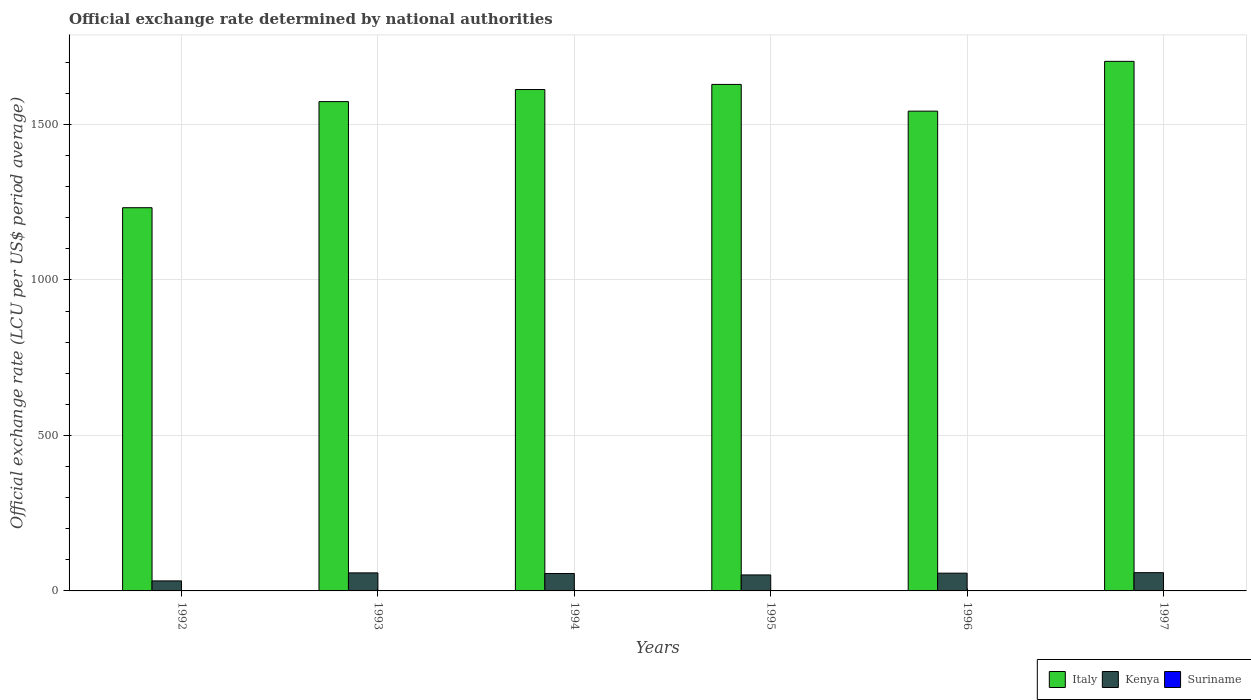Are the number of bars per tick equal to the number of legend labels?
Offer a terse response. Yes. Are the number of bars on each tick of the X-axis equal?
Your answer should be compact. Yes. How many bars are there on the 1st tick from the left?
Your answer should be very brief. 3. How many bars are there on the 5th tick from the right?
Your answer should be very brief. 3. What is the label of the 5th group of bars from the left?
Offer a very short reply. 1996. What is the official exchange rate in Italy in 1996?
Your answer should be very brief. 1542.95. Across all years, what is the maximum official exchange rate in Suriname?
Your answer should be very brief. 0.44. Across all years, what is the minimum official exchange rate in Suriname?
Provide a short and direct response. 0. In which year was the official exchange rate in Italy maximum?
Provide a succinct answer. 1997. What is the total official exchange rate in Kenya in the graph?
Give a very brief answer. 313.55. What is the difference between the official exchange rate in Kenya in 1993 and that in 1996?
Keep it short and to the point. 0.89. What is the difference between the official exchange rate in Suriname in 1992 and the official exchange rate in Italy in 1993?
Ensure brevity in your answer.  -1573.66. What is the average official exchange rate in Kenya per year?
Offer a very short reply. 52.26. In the year 1994, what is the difference between the official exchange rate in Kenya and official exchange rate in Italy?
Offer a terse response. -1556.39. What is the ratio of the official exchange rate in Italy in 1992 to that in 1997?
Offer a terse response. 0.72. Is the official exchange rate in Suriname in 1993 less than that in 1996?
Ensure brevity in your answer.  Yes. Is the difference between the official exchange rate in Kenya in 1992 and 1994 greater than the difference between the official exchange rate in Italy in 1992 and 1994?
Your response must be concise. Yes. What is the difference between the highest and the second highest official exchange rate in Suriname?
Your answer should be very brief. 0.04. What is the difference between the highest and the lowest official exchange rate in Suriname?
Give a very brief answer. 0.44. In how many years, is the official exchange rate in Suriname greater than the average official exchange rate in Suriname taken over all years?
Offer a terse response. 3. What does the 3rd bar from the left in 1993 represents?
Make the answer very short. Suriname. What does the 2nd bar from the right in 1994 represents?
Provide a short and direct response. Kenya. Is it the case that in every year, the sum of the official exchange rate in Kenya and official exchange rate in Suriname is greater than the official exchange rate in Italy?
Make the answer very short. No. How many bars are there?
Make the answer very short. 18. Are all the bars in the graph horizontal?
Your answer should be very brief. No. How many years are there in the graph?
Provide a short and direct response. 6. What is the difference between two consecutive major ticks on the Y-axis?
Provide a succinct answer. 500. Does the graph contain any zero values?
Offer a terse response. No. What is the title of the graph?
Keep it short and to the point. Official exchange rate determined by national authorities. What is the label or title of the X-axis?
Your response must be concise. Years. What is the label or title of the Y-axis?
Give a very brief answer. Official exchange rate (LCU per US$ period average). What is the Official exchange rate (LCU per US$ period average) in Italy in 1992?
Your answer should be very brief. 1232.41. What is the Official exchange rate (LCU per US$ period average) in Kenya in 1992?
Your answer should be compact. 32.22. What is the Official exchange rate (LCU per US$ period average) in Suriname in 1992?
Ensure brevity in your answer.  0. What is the Official exchange rate (LCU per US$ period average) of Italy in 1993?
Provide a succinct answer. 1573.67. What is the Official exchange rate (LCU per US$ period average) in Kenya in 1993?
Your response must be concise. 58. What is the Official exchange rate (LCU per US$ period average) in Suriname in 1993?
Ensure brevity in your answer.  0. What is the Official exchange rate (LCU per US$ period average) in Italy in 1994?
Your answer should be very brief. 1612.44. What is the Official exchange rate (LCU per US$ period average) in Kenya in 1994?
Provide a short and direct response. 56.05. What is the Official exchange rate (LCU per US$ period average) in Suriname in 1994?
Your answer should be very brief. 0.22. What is the Official exchange rate (LCU per US$ period average) in Italy in 1995?
Offer a very short reply. 1628.93. What is the Official exchange rate (LCU per US$ period average) in Kenya in 1995?
Give a very brief answer. 51.43. What is the Official exchange rate (LCU per US$ period average) of Suriname in 1995?
Offer a terse response. 0.44. What is the Official exchange rate (LCU per US$ period average) in Italy in 1996?
Offer a very short reply. 1542.95. What is the Official exchange rate (LCU per US$ period average) of Kenya in 1996?
Keep it short and to the point. 57.11. What is the Official exchange rate (LCU per US$ period average) in Suriname in 1996?
Make the answer very short. 0.4. What is the Official exchange rate (LCU per US$ period average) in Italy in 1997?
Provide a short and direct response. 1703.1. What is the Official exchange rate (LCU per US$ period average) in Kenya in 1997?
Offer a terse response. 58.73. What is the Official exchange rate (LCU per US$ period average) in Suriname in 1997?
Offer a terse response. 0.4. Across all years, what is the maximum Official exchange rate (LCU per US$ period average) in Italy?
Make the answer very short. 1703.1. Across all years, what is the maximum Official exchange rate (LCU per US$ period average) in Kenya?
Make the answer very short. 58.73. Across all years, what is the maximum Official exchange rate (LCU per US$ period average) in Suriname?
Ensure brevity in your answer.  0.44. Across all years, what is the minimum Official exchange rate (LCU per US$ period average) of Italy?
Offer a very short reply. 1232.41. Across all years, what is the minimum Official exchange rate (LCU per US$ period average) in Kenya?
Provide a short and direct response. 32.22. Across all years, what is the minimum Official exchange rate (LCU per US$ period average) in Suriname?
Provide a succinct answer. 0. What is the total Official exchange rate (LCU per US$ period average) in Italy in the graph?
Provide a succinct answer. 9293.49. What is the total Official exchange rate (LCU per US$ period average) in Kenya in the graph?
Offer a terse response. 313.55. What is the total Official exchange rate (LCU per US$ period average) in Suriname in the graph?
Provide a succinct answer. 1.47. What is the difference between the Official exchange rate (LCU per US$ period average) in Italy in 1992 and that in 1993?
Your answer should be very brief. -341.26. What is the difference between the Official exchange rate (LCU per US$ period average) in Kenya in 1992 and that in 1993?
Give a very brief answer. -25.78. What is the difference between the Official exchange rate (LCU per US$ period average) of Suriname in 1992 and that in 1993?
Keep it short and to the point. 0. What is the difference between the Official exchange rate (LCU per US$ period average) of Italy in 1992 and that in 1994?
Give a very brief answer. -380.04. What is the difference between the Official exchange rate (LCU per US$ period average) in Kenya in 1992 and that in 1994?
Offer a terse response. -23.83. What is the difference between the Official exchange rate (LCU per US$ period average) in Suriname in 1992 and that in 1994?
Your answer should be compact. -0.22. What is the difference between the Official exchange rate (LCU per US$ period average) in Italy in 1992 and that in 1995?
Your answer should be very brief. -396.53. What is the difference between the Official exchange rate (LCU per US$ period average) of Kenya in 1992 and that in 1995?
Ensure brevity in your answer.  -19.21. What is the difference between the Official exchange rate (LCU per US$ period average) of Suriname in 1992 and that in 1995?
Offer a terse response. -0.44. What is the difference between the Official exchange rate (LCU per US$ period average) in Italy in 1992 and that in 1996?
Your answer should be very brief. -310.54. What is the difference between the Official exchange rate (LCU per US$ period average) of Kenya in 1992 and that in 1996?
Keep it short and to the point. -24.9. What is the difference between the Official exchange rate (LCU per US$ period average) in Suriname in 1992 and that in 1996?
Provide a short and direct response. -0.4. What is the difference between the Official exchange rate (LCU per US$ period average) in Italy in 1992 and that in 1997?
Make the answer very short. -470.69. What is the difference between the Official exchange rate (LCU per US$ period average) in Kenya in 1992 and that in 1997?
Ensure brevity in your answer.  -26.52. What is the difference between the Official exchange rate (LCU per US$ period average) in Suriname in 1992 and that in 1997?
Offer a terse response. -0.4. What is the difference between the Official exchange rate (LCU per US$ period average) of Italy in 1993 and that in 1994?
Ensure brevity in your answer.  -38.78. What is the difference between the Official exchange rate (LCU per US$ period average) of Kenya in 1993 and that in 1994?
Keep it short and to the point. 1.95. What is the difference between the Official exchange rate (LCU per US$ period average) in Suriname in 1993 and that in 1994?
Your response must be concise. -0.22. What is the difference between the Official exchange rate (LCU per US$ period average) in Italy in 1993 and that in 1995?
Make the answer very short. -55.27. What is the difference between the Official exchange rate (LCU per US$ period average) of Kenya in 1993 and that in 1995?
Give a very brief answer. 6.57. What is the difference between the Official exchange rate (LCU per US$ period average) of Suriname in 1993 and that in 1995?
Offer a very short reply. -0.44. What is the difference between the Official exchange rate (LCU per US$ period average) of Italy in 1993 and that in 1996?
Keep it short and to the point. 30.72. What is the difference between the Official exchange rate (LCU per US$ period average) of Kenya in 1993 and that in 1996?
Your answer should be compact. 0.89. What is the difference between the Official exchange rate (LCU per US$ period average) of Suriname in 1993 and that in 1996?
Provide a succinct answer. -0.4. What is the difference between the Official exchange rate (LCU per US$ period average) in Italy in 1993 and that in 1997?
Keep it short and to the point. -129.43. What is the difference between the Official exchange rate (LCU per US$ period average) in Kenya in 1993 and that in 1997?
Provide a short and direct response. -0.73. What is the difference between the Official exchange rate (LCU per US$ period average) in Suriname in 1993 and that in 1997?
Your response must be concise. -0.4. What is the difference between the Official exchange rate (LCU per US$ period average) in Italy in 1994 and that in 1995?
Your response must be concise. -16.49. What is the difference between the Official exchange rate (LCU per US$ period average) of Kenya in 1994 and that in 1995?
Give a very brief answer. 4.62. What is the difference between the Official exchange rate (LCU per US$ period average) in Suriname in 1994 and that in 1995?
Provide a short and direct response. -0.22. What is the difference between the Official exchange rate (LCU per US$ period average) in Italy in 1994 and that in 1996?
Provide a succinct answer. 69.5. What is the difference between the Official exchange rate (LCU per US$ period average) in Kenya in 1994 and that in 1996?
Make the answer very short. -1.06. What is the difference between the Official exchange rate (LCU per US$ period average) in Suriname in 1994 and that in 1996?
Keep it short and to the point. -0.18. What is the difference between the Official exchange rate (LCU per US$ period average) of Italy in 1994 and that in 1997?
Your answer should be compact. -90.65. What is the difference between the Official exchange rate (LCU per US$ period average) in Kenya in 1994 and that in 1997?
Make the answer very short. -2.68. What is the difference between the Official exchange rate (LCU per US$ period average) in Suriname in 1994 and that in 1997?
Your answer should be very brief. -0.18. What is the difference between the Official exchange rate (LCU per US$ period average) of Italy in 1995 and that in 1996?
Provide a short and direct response. 85.99. What is the difference between the Official exchange rate (LCU per US$ period average) of Kenya in 1995 and that in 1996?
Offer a very short reply. -5.68. What is the difference between the Official exchange rate (LCU per US$ period average) in Suriname in 1995 and that in 1996?
Give a very brief answer. 0.04. What is the difference between the Official exchange rate (LCU per US$ period average) in Italy in 1995 and that in 1997?
Offer a very short reply. -74.16. What is the difference between the Official exchange rate (LCU per US$ period average) in Kenya in 1995 and that in 1997?
Offer a terse response. -7.3. What is the difference between the Official exchange rate (LCU per US$ period average) in Suriname in 1995 and that in 1997?
Your answer should be very brief. 0.04. What is the difference between the Official exchange rate (LCU per US$ period average) of Italy in 1996 and that in 1997?
Offer a terse response. -160.15. What is the difference between the Official exchange rate (LCU per US$ period average) of Kenya in 1996 and that in 1997?
Offer a very short reply. -1.62. What is the difference between the Official exchange rate (LCU per US$ period average) of Suriname in 1996 and that in 1997?
Offer a terse response. -0. What is the difference between the Official exchange rate (LCU per US$ period average) in Italy in 1992 and the Official exchange rate (LCU per US$ period average) in Kenya in 1993?
Keep it short and to the point. 1174.4. What is the difference between the Official exchange rate (LCU per US$ period average) in Italy in 1992 and the Official exchange rate (LCU per US$ period average) in Suriname in 1993?
Offer a terse response. 1232.4. What is the difference between the Official exchange rate (LCU per US$ period average) in Kenya in 1992 and the Official exchange rate (LCU per US$ period average) in Suriname in 1993?
Your response must be concise. 32.22. What is the difference between the Official exchange rate (LCU per US$ period average) of Italy in 1992 and the Official exchange rate (LCU per US$ period average) of Kenya in 1994?
Your answer should be compact. 1176.36. What is the difference between the Official exchange rate (LCU per US$ period average) in Italy in 1992 and the Official exchange rate (LCU per US$ period average) in Suriname in 1994?
Provide a short and direct response. 1232.18. What is the difference between the Official exchange rate (LCU per US$ period average) of Kenya in 1992 and the Official exchange rate (LCU per US$ period average) of Suriname in 1994?
Keep it short and to the point. 31.99. What is the difference between the Official exchange rate (LCU per US$ period average) in Italy in 1992 and the Official exchange rate (LCU per US$ period average) in Kenya in 1995?
Offer a very short reply. 1180.98. What is the difference between the Official exchange rate (LCU per US$ period average) in Italy in 1992 and the Official exchange rate (LCU per US$ period average) in Suriname in 1995?
Give a very brief answer. 1231.96. What is the difference between the Official exchange rate (LCU per US$ period average) of Kenya in 1992 and the Official exchange rate (LCU per US$ period average) of Suriname in 1995?
Your answer should be very brief. 31.77. What is the difference between the Official exchange rate (LCU per US$ period average) in Italy in 1992 and the Official exchange rate (LCU per US$ period average) in Kenya in 1996?
Offer a terse response. 1175.29. What is the difference between the Official exchange rate (LCU per US$ period average) in Italy in 1992 and the Official exchange rate (LCU per US$ period average) in Suriname in 1996?
Your answer should be compact. 1232. What is the difference between the Official exchange rate (LCU per US$ period average) of Kenya in 1992 and the Official exchange rate (LCU per US$ period average) of Suriname in 1996?
Your response must be concise. 31.82. What is the difference between the Official exchange rate (LCU per US$ period average) in Italy in 1992 and the Official exchange rate (LCU per US$ period average) in Kenya in 1997?
Offer a very short reply. 1173.67. What is the difference between the Official exchange rate (LCU per US$ period average) in Italy in 1992 and the Official exchange rate (LCU per US$ period average) in Suriname in 1997?
Provide a succinct answer. 1232. What is the difference between the Official exchange rate (LCU per US$ period average) of Kenya in 1992 and the Official exchange rate (LCU per US$ period average) of Suriname in 1997?
Offer a terse response. 31.82. What is the difference between the Official exchange rate (LCU per US$ period average) in Italy in 1993 and the Official exchange rate (LCU per US$ period average) in Kenya in 1994?
Give a very brief answer. 1517.62. What is the difference between the Official exchange rate (LCU per US$ period average) in Italy in 1993 and the Official exchange rate (LCU per US$ period average) in Suriname in 1994?
Provide a succinct answer. 1573.44. What is the difference between the Official exchange rate (LCU per US$ period average) of Kenya in 1993 and the Official exchange rate (LCU per US$ period average) of Suriname in 1994?
Provide a succinct answer. 57.78. What is the difference between the Official exchange rate (LCU per US$ period average) of Italy in 1993 and the Official exchange rate (LCU per US$ period average) of Kenya in 1995?
Offer a very short reply. 1522.24. What is the difference between the Official exchange rate (LCU per US$ period average) of Italy in 1993 and the Official exchange rate (LCU per US$ period average) of Suriname in 1995?
Offer a very short reply. 1573.22. What is the difference between the Official exchange rate (LCU per US$ period average) in Kenya in 1993 and the Official exchange rate (LCU per US$ period average) in Suriname in 1995?
Your response must be concise. 57.56. What is the difference between the Official exchange rate (LCU per US$ period average) in Italy in 1993 and the Official exchange rate (LCU per US$ period average) in Kenya in 1996?
Offer a very short reply. 1516.55. What is the difference between the Official exchange rate (LCU per US$ period average) in Italy in 1993 and the Official exchange rate (LCU per US$ period average) in Suriname in 1996?
Make the answer very short. 1573.26. What is the difference between the Official exchange rate (LCU per US$ period average) in Kenya in 1993 and the Official exchange rate (LCU per US$ period average) in Suriname in 1996?
Keep it short and to the point. 57.6. What is the difference between the Official exchange rate (LCU per US$ period average) of Italy in 1993 and the Official exchange rate (LCU per US$ period average) of Kenya in 1997?
Keep it short and to the point. 1514.93. What is the difference between the Official exchange rate (LCU per US$ period average) of Italy in 1993 and the Official exchange rate (LCU per US$ period average) of Suriname in 1997?
Make the answer very short. 1573.26. What is the difference between the Official exchange rate (LCU per US$ period average) of Kenya in 1993 and the Official exchange rate (LCU per US$ period average) of Suriname in 1997?
Ensure brevity in your answer.  57.6. What is the difference between the Official exchange rate (LCU per US$ period average) in Italy in 1994 and the Official exchange rate (LCU per US$ period average) in Kenya in 1995?
Your answer should be compact. 1561.02. What is the difference between the Official exchange rate (LCU per US$ period average) in Italy in 1994 and the Official exchange rate (LCU per US$ period average) in Suriname in 1995?
Offer a terse response. 1612. What is the difference between the Official exchange rate (LCU per US$ period average) of Kenya in 1994 and the Official exchange rate (LCU per US$ period average) of Suriname in 1995?
Ensure brevity in your answer.  55.61. What is the difference between the Official exchange rate (LCU per US$ period average) in Italy in 1994 and the Official exchange rate (LCU per US$ period average) in Kenya in 1996?
Your answer should be compact. 1555.33. What is the difference between the Official exchange rate (LCU per US$ period average) in Italy in 1994 and the Official exchange rate (LCU per US$ period average) in Suriname in 1996?
Offer a very short reply. 1612.04. What is the difference between the Official exchange rate (LCU per US$ period average) in Kenya in 1994 and the Official exchange rate (LCU per US$ period average) in Suriname in 1996?
Provide a succinct answer. 55.65. What is the difference between the Official exchange rate (LCU per US$ period average) in Italy in 1994 and the Official exchange rate (LCU per US$ period average) in Kenya in 1997?
Provide a short and direct response. 1553.71. What is the difference between the Official exchange rate (LCU per US$ period average) in Italy in 1994 and the Official exchange rate (LCU per US$ period average) in Suriname in 1997?
Provide a short and direct response. 1612.04. What is the difference between the Official exchange rate (LCU per US$ period average) in Kenya in 1994 and the Official exchange rate (LCU per US$ period average) in Suriname in 1997?
Give a very brief answer. 55.65. What is the difference between the Official exchange rate (LCU per US$ period average) in Italy in 1995 and the Official exchange rate (LCU per US$ period average) in Kenya in 1996?
Offer a terse response. 1571.82. What is the difference between the Official exchange rate (LCU per US$ period average) of Italy in 1995 and the Official exchange rate (LCU per US$ period average) of Suriname in 1996?
Give a very brief answer. 1628.53. What is the difference between the Official exchange rate (LCU per US$ period average) of Kenya in 1995 and the Official exchange rate (LCU per US$ period average) of Suriname in 1996?
Your response must be concise. 51.03. What is the difference between the Official exchange rate (LCU per US$ period average) in Italy in 1995 and the Official exchange rate (LCU per US$ period average) in Kenya in 1997?
Offer a very short reply. 1570.2. What is the difference between the Official exchange rate (LCU per US$ period average) in Italy in 1995 and the Official exchange rate (LCU per US$ period average) in Suriname in 1997?
Offer a terse response. 1628.53. What is the difference between the Official exchange rate (LCU per US$ period average) of Kenya in 1995 and the Official exchange rate (LCU per US$ period average) of Suriname in 1997?
Make the answer very short. 51.03. What is the difference between the Official exchange rate (LCU per US$ period average) of Italy in 1996 and the Official exchange rate (LCU per US$ period average) of Kenya in 1997?
Give a very brief answer. 1484.22. What is the difference between the Official exchange rate (LCU per US$ period average) of Italy in 1996 and the Official exchange rate (LCU per US$ period average) of Suriname in 1997?
Your response must be concise. 1542.55. What is the difference between the Official exchange rate (LCU per US$ period average) in Kenya in 1996 and the Official exchange rate (LCU per US$ period average) in Suriname in 1997?
Ensure brevity in your answer.  56.71. What is the average Official exchange rate (LCU per US$ period average) of Italy per year?
Your answer should be very brief. 1548.92. What is the average Official exchange rate (LCU per US$ period average) in Kenya per year?
Give a very brief answer. 52.26. What is the average Official exchange rate (LCU per US$ period average) in Suriname per year?
Your answer should be very brief. 0.25. In the year 1992, what is the difference between the Official exchange rate (LCU per US$ period average) in Italy and Official exchange rate (LCU per US$ period average) in Kenya?
Your answer should be compact. 1200.19. In the year 1992, what is the difference between the Official exchange rate (LCU per US$ period average) in Italy and Official exchange rate (LCU per US$ period average) in Suriname?
Offer a terse response. 1232.4. In the year 1992, what is the difference between the Official exchange rate (LCU per US$ period average) of Kenya and Official exchange rate (LCU per US$ period average) of Suriname?
Offer a very short reply. 32.22. In the year 1993, what is the difference between the Official exchange rate (LCU per US$ period average) of Italy and Official exchange rate (LCU per US$ period average) of Kenya?
Provide a succinct answer. 1515.66. In the year 1993, what is the difference between the Official exchange rate (LCU per US$ period average) in Italy and Official exchange rate (LCU per US$ period average) in Suriname?
Ensure brevity in your answer.  1573.66. In the year 1993, what is the difference between the Official exchange rate (LCU per US$ period average) in Kenya and Official exchange rate (LCU per US$ period average) in Suriname?
Ensure brevity in your answer.  58. In the year 1994, what is the difference between the Official exchange rate (LCU per US$ period average) of Italy and Official exchange rate (LCU per US$ period average) of Kenya?
Give a very brief answer. 1556.39. In the year 1994, what is the difference between the Official exchange rate (LCU per US$ period average) of Italy and Official exchange rate (LCU per US$ period average) of Suriname?
Give a very brief answer. 1612.22. In the year 1994, what is the difference between the Official exchange rate (LCU per US$ period average) in Kenya and Official exchange rate (LCU per US$ period average) in Suriname?
Provide a succinct answer. 55.83. In the year 1995, what is the difference between the Official exchange rate (LCU per US$ period average) of Italy and Official exchange rate (LCU per US$ period average) of Kenya?
Your answer should be very brief. 1577.5. In the year 1995, what is the difference between the Official exchange rate (LCU per US$ period average) of Italy and Official exchange rate (LCU per US$ period average) of Suriname?
Your response must be concise. 1628.49. In the year 1995, what is the difference between the Official exchange rate (LCU per US$ period average) of Kenya and Official exchange rate (LCU per US$ period average) of Suriname?
Ensure brevity in your answer.  50.99. In the year 1996, what is the difference between the Official exchange rate (LCU per US$ period average) of Italy and Official exchange rate (LCU per US$ period average) of Kenya?
Offer a terse response. 1485.83. In the year 1996, what is the difference between the Official exchange rate (LCU per US$ period average) in Italy and Official exchange rate (LCU per US$ period average) in Suriname?
Offer a very short reply. 1542.55. In the year 1996, what is the difference between the Official exchange rate (LCU per US$ period average) of Kenya and Official exchange rate (LCU per US$ period average) of Suriname?
Offer a terse response. 56.71. In the year 1997, what is the difference between the Official exchange rate (LCU per US$ period average) of Italy and Official exchange rate (LCU per US$ period average) of Kenya?
Give a very brief answer. 1644.37. In the year 1997, what is the difference between the Official exchange rate (LCU per US$ period average) in Italy and Official exchange rate (LCU per US$ period average) in Suriname?
Your answer should be compact. 1702.7. In the year 1997, what is the difference between the Official exchange rate (LCU per US$ period average) in Kenya and Official exchange rate (LCU per US$ period average) in Suriname?
Offer a terse response. 58.33. What is the ratio of the Official exchange rate (LCU per US$ period average) of Italy in 1992 to that in 1993?
Ensure brevity in your answer.  0.78. What is the ratio of the Official exchange rate (LCU per US$ period average) of Kenya in 1992 to that in 1993?
Give a very brief answer. 0.56. What is the ratio of the Official exchange rate (LCU per US$ period average) in Suriname in 1992 to that in 1993?
Provide a short and direct response. 1. What is the ratio of the Official exchange rate (LCU per US$ period average) of Italy in 1992 to that in 1994?
Make the answer very short. 0.76. What is the ratio of the Official exchange rate (LCU per US$ period average) in Kenya in 1992 to that in 1994?
Provide a succinct answer. 0.57. What is the ratio of the Official exchange rate (LCU per US$ period average) in Suriname in 1992 to that in 1994?
Provide a succinct answer. 0.01. What is the ratio of the Official exchange rate (LCU per US$ period average) in Italy in 1992 to that in 1995?
Your response must be concise. 0.76. What is the ratio of the Official exchange rate (LCU per US$ period average) of Kenya in 1992 to that in 1995?
Your response must be concise. 0.63. What is the ratio of the Official exchange rate (LCU per US$ period average) in Suriname in 1992 to that in 1995?
Make the answer very short. 0. What is the ratio of the Official exchange rate (LCU per US$ period average) of Italy in 1992 to that in 1996?
Provide a succinct answer. 0.8. What is the ratio of the Official exchange rate (LCU per US$ period average) of Kenya in 1992 to that in 1996?
Give a very brief answer. 0.56. What is the ratio of the Official exchange rate (LCU per US$ period average) of Suriname in 1992 to that in 1996?
Provide a succinct answer. 0. What is the ratio of the Official exchange rate (LCU per US$ period average) of Italy in 1992 to that in 1997?
Offer a terse response. 0.72. What is the ratio of the Official exchange rate (LCU per US$ period average) of Kenya in 1992 to that in 1997?
Offer a very short reply. 0.55. What is the ratio of the Official exchange rate (LCU per US$ period average) of Suriname in 1992 to that in 1997?
Give a very brief answer. 0. What is the ratio of the Official exchange rate (LCU per US$ period average) of Italy in 1993 to that in 1994?
Your answer should be very brief. 0.98. What is the ratio of the Official exchange rate (LCU per US$ period average) of Kenya in 1993 to that in 1994?
Give a very brief answer. 1.03. What is the ratio of the Official exchange rate (LCU per US$ period average) in Suriname in 1993 to that in 1994?
Provide a succinct answer. 0.01. What is the ratio of the Official exchange rate (LCU per US$ period average) of Italy in 1993 to that in 1995?
Provide a short and direct response. 0.97. What is the ratio of the Official exchange rate (LCU per US$ period average) of Kenya in 1993 to that in 1995?
Your response must be concise. 1.13. What is the ratio of the Official exchange rate (LCU per US$ period average) in Suriname in 1993 to that in 1995?
Provide a short and direct response. 0. What is the ratio of the Official exchange rate (LCU per US$ period average) in Italy in 1993 to that in 1996?
Keep it short and to the point. 1.02. What is the ratio of the Official exchange rate (LCU per US$ period average) in Kenya in 1993 to that in 1996?
Give a very brief answer. 1.02. What is the ratio of the Official exchange rate (LCU per US$ period average) of Suriname in 1993 to that in 1996?
Your response must be concise. 0. What is the ratio of the Official exchange rate (LCU per US$ period average) of Italy in 1993 to that in 1997?
Make the answer very short. 0.92. What is the ratio of the Official exchange rate (LCU per US$ period average) of Kenya in 1993 to that in 1997?
Offer a terse response. 0.99. What is the ratio of the Official exchange rate (LCU per US$ period average) in Suriname in 1993 to that in 1997?
Your answer should be very brief. 0. What is the ratio of the Official exchange rate (LCU per US$ period average) of Kenya in 1994 to that in 1995?
Give a very brief answer. 1.09. What is the ratio of the Official exchange rate (LCU per US$ period average) in Suriname in 1994 to that in 1995?
Your response must be concise. 0.5. What is the ratio of the Official exchange rate (LCU per US$ period average) of Italy in 1994 to that in 1996?
Keep it short and to the point. 1.04. What is the ratio of the Official exchange rate (LCU per US$ period average) of Kenya in 1994 to that in 1996?
Provide a succinct answer. 0.98. What is the ratio of the Official exchange rate (LCU per US$ period average) of Suriname in 1994 to that in 1996?
Give a very brief answer. 0.55. What is the ratio of the Official exchange rate (LCU per US$ period average) of Italy in 1994 to that in 1997?
Your answer should be very brief. 0.95. What is the ratio of the Official exchange rate (LCU per US$ period average) in Kenya in 1994 to that in 1997?
Make the answer very short. 0.95. What is the ratio of the Official exchange rate (LCU per US$ period average) of Suriname in 1994 to that in 1997?
Offer a very short reply. 0.55. What is the ratio of the Official exchange rate (LCU per US$ period average) of Italy in 1995 to that in 1996?
Provide a short and direct response. 1.06. What is the ratio of the Official exchange rate (LCU per US$ period average) of Kenya in 1995 to that in 1996?
Ensure brevity in your answer.  0.9. What is the ratio of the Official exchange rate (LCU per US$ period average) of Suriname in 1995 to that in 1996?
Provide a succinct answer. 1.1. What is the ratio of the Official exchange rate (LCU per US$ period average) in Italy in 1995 to that in 1997?
Your answer should be compact. 0.96. What is the ratio of the Official exchange rate (LCU per US$ period average) in Kenya in 1995 to that in 1997?
Offer a terse response. 0.88. What is the ratio of the Official exchange rate (LCU per US$ period average) in Suriname in 1995 to that in 1997?
Give a very brief answer. 1.1. What is the ratio of the Official exchange rate (LCU per US$ period average) of Italy in 1996 to that in 1997?
Your answer should be very brief. 0.91. What is the ratio of the Official exchange rate (LCU per US$ period average) of Kenya in 1996 to that in 1997?
Give a very brief answer. 0.97. What is the difference between the highest and the second highest Official exchange rate (LCU per US$ period average) in Italy?
Give a very brief answer. 74.16. What is the difference between the highest and the second highest Official exchange rate (LCU per US$ period average) in Kenya?
Ensure brevity in your answer.  0.73. What is the difference between the highest and the second highest Official exchange rate (LCU per US$ period average) of Suriname?
Provide a short and direct response. 0.04. What is the difference between the highest and the lowest Official exchange rate (LCU per US$ period average) in Italy?
Provide a short and direct response. 470.69. What is the difference between the highest and the lowest Official exchange rate (LCU per US$ period average) in Kenya?
Offer a very short reply. 26.52. What is the difference between the highest and the lowest Official exchange rate (LCU per US$ period average) in Suriname?
Give a very brief answer. 0.44. 